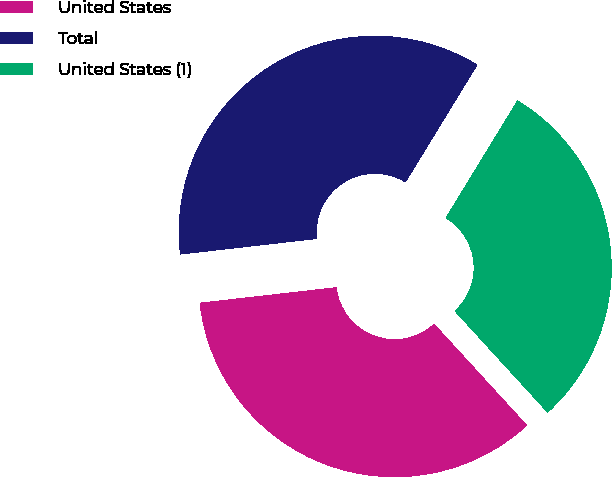<chart> <loc_0><loc_0><loc_500><loc_500><pie_chart><fcel>United States<fcel>Total<fcel>United States (1)<nl><fcel>34.99%<fcel>35.54%<fcel>29.47%<nl></chart> 